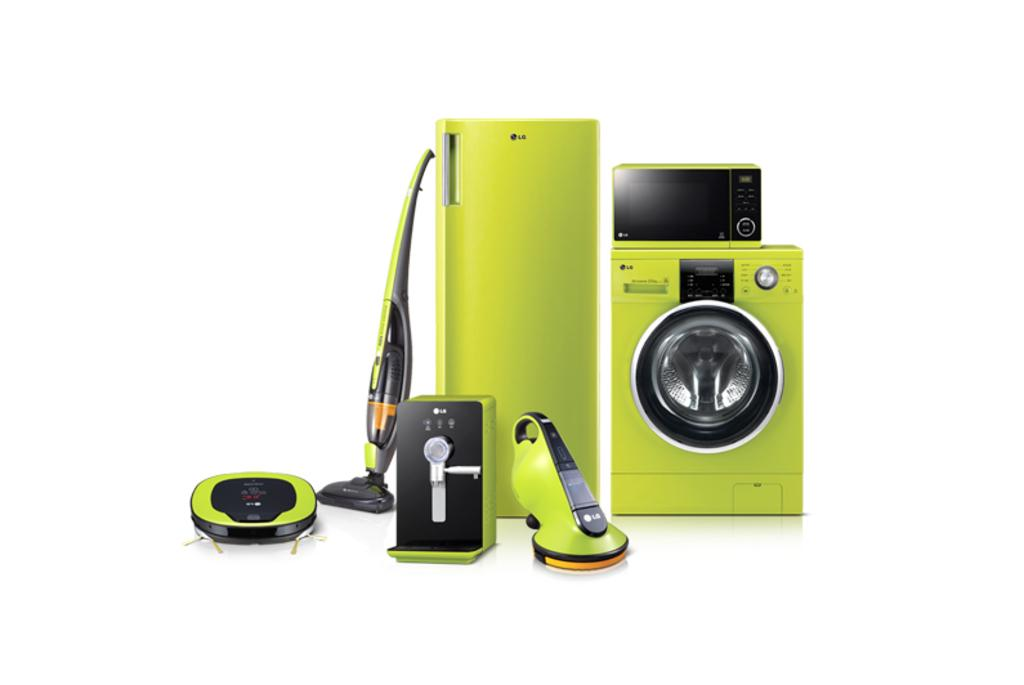What type of appliance can be seen in the image? There is a washing machine, refrigerator, and oven in the image. What other electronics are present in the image? There are other electronics in the image, but their specific types are not mentioned. Can you describe the purpose of each appliance in the image? The washing machine is used for cleaning clothes, the refrigerator is used for storing food, and the oven is used for cooking or baking. How many yaks are visible in the image? There are no yaks present in the image. What idea does the washing machine have about the refrigerator in the image? The image does not depict appliances with the ability to have ideas or communicate with each other. 